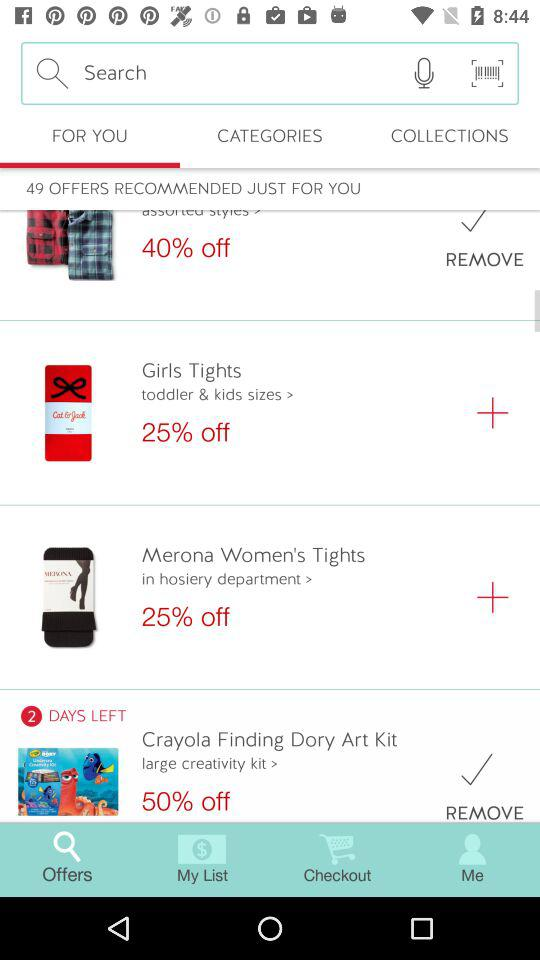How many days are left for the end of the discount on a Crayola finding dory art kit? There are 2 days left until the end of the discount. 